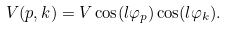Convert formula to latex. <formula><loc_0><loc_0><loc_500><loc_500>V ( { p } , { k } ) = V \cos ( l \varphi _ { p } ) \cos ( l \varphi _ { k } ) .</formula> 